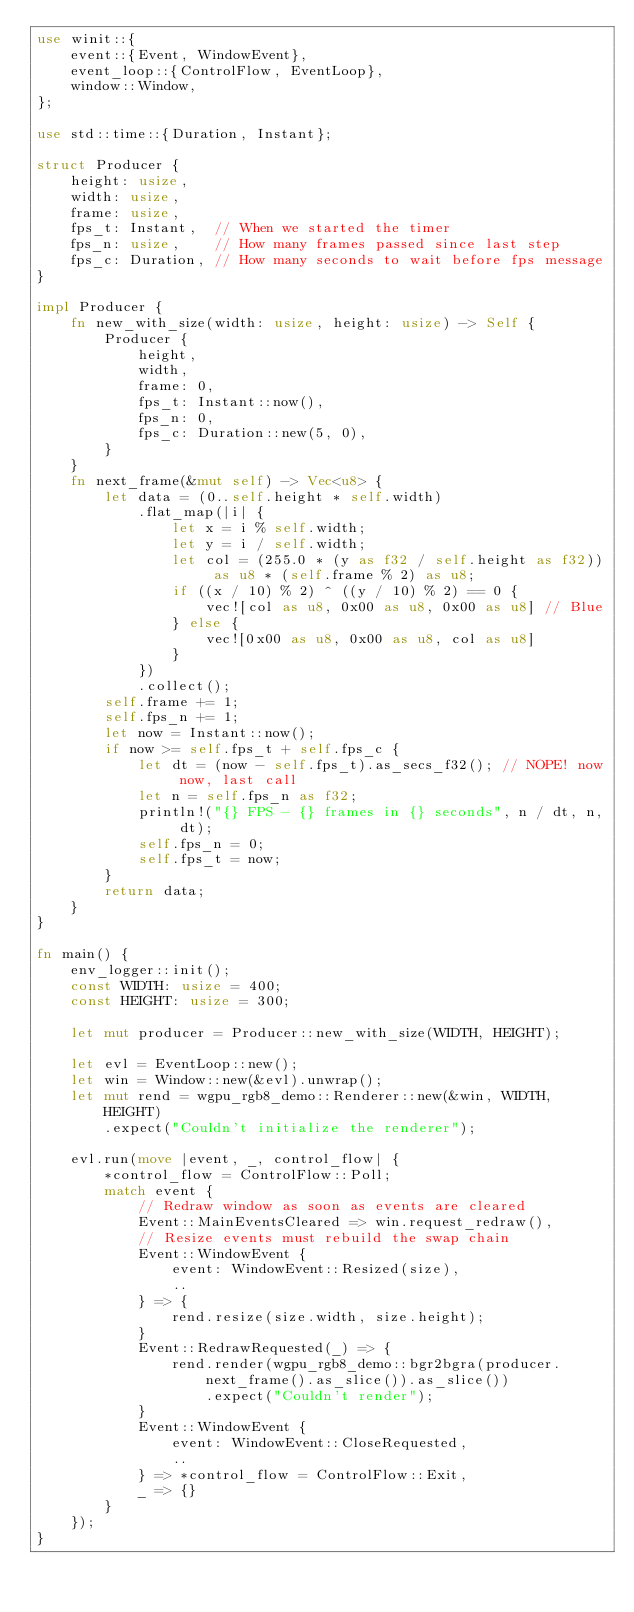<code> <loc_0><loc_0><loc_500><loc_500><_Rust_>use winit::{
    event::{Event, WindowEvent},
    event_loop::{ControlFlow, EventLoop},
    window::Window,
};

use std::time::{Duration, Instant};

struct Producer {
    height: usize,
    width: usize,
    frame: usize,
    fps_t: Instant,  // When we started the timer
    fps_n: usize,    // How many frames passed since last step
    fps_c: Duration, // How many seconds to wait before fps message
}

impl Producer {
    fn new_with_size(width: usize, height: usize) -> Self {
        Producer {
            height,
            width,
            frame: 0,
            fps_t: Instant::now(),
            fps_n: 0,
            fps_c: Duration::new(5, 0),
        }
    }
    fn next_frame(&mut self) -> Vec<u8> {
        let data = (0..self.height * self.width)
            .flat_map(|i| {
                let x = i % self.width;
                let y = i / self.width;
                let col = (255.0 * (y as f32 / self.height as f32)) as u8 * (self.frame % 2) as u8;
                if ((x / 10) % 2) ^ ((y / 10) % 2) == 0 {
                    vec![col as u8, 0x00 as u8, 0x00 as u8] // Blue
                } else {
                    vec![0x00 as u8, 0x00 as u8, col as u8]
                }
            })
            .collect();
        self.frame += 1;
        self.fps_n += 1;
        let now = Instant::now();
        if now >= self.fps_t + self.fps_c {
            let dt = (now - self.fps_t).as_secs_f32(); // NOPE! now now, last call
            let n = self.fps_n as f32;
            println!("{} FPS - {} frames in {} seconds", n / dt, n, dt);
            self.fps_n = 0;
            self.fps_t = now;
        }
        return data;
    }
}

fn main() {
    env_logger::init();
    const WIDTH: usize = 400;
    const HEIGHT: usize = 300;

    let mut producer = Producer::new_with_size(WIDTH, HEIGHT);

    let evl = EventLoop::new();
    let win = Window::new(&evl).unwrap();
    let mut rend = wgpu_rgb8_demo::Renderer::new(&win, WIDTH, HEIGHT)
        .expect("Couldn't initialize the renderer");

    evl.run(move |event, _, control_flow| {
        *control_flow = ControlFlow::Poll;
        match event {
            // Redraw window as soon as events are cleared
            Event::MainEventsCleared => win.request_redraw(),
            // Resize events must rebuild the swap chain
            Event::WindowEvent {
                event: WindowEvent::Resized(size),
                ..
            } => {
                rend.resize(size.width, size.height);
            }
            Event::RedrawRequested(_) => {
                rend.render(wgpu_rgb8_demo::bgr2bgra(producer.next_frame().as_slice()).as_slice())
                    .expect("Couldn't render");
            }
            Event::WindowEvent {
                event: WindowEvent::CloseRequested,
                ..
            } => *control_flow = ControlFlow::Exit,
            _ => {}
        }
    });
}
</code> 